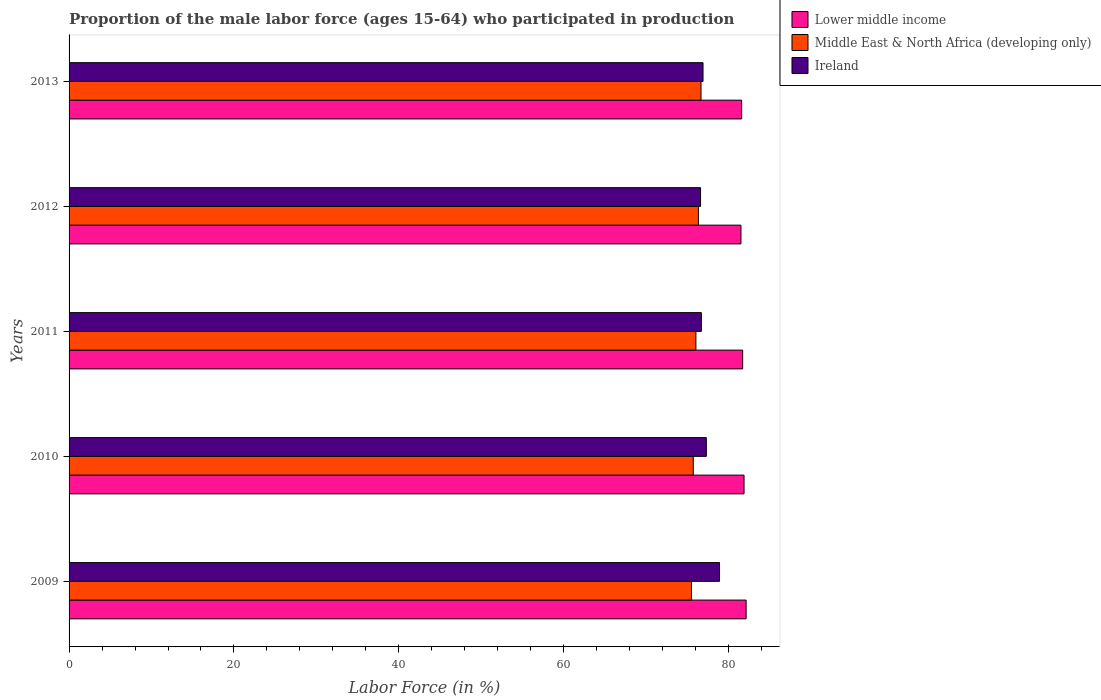Are the number of bars per tick equal to the number of legend labels?
Make the answer very short. Yes. Are the number of bars on each tick of the Y-axis equal?
Keep it short and to the point. Yes. What is the label of the 2nd group of bars from the top?
Provide a succinct answer. 2012. In how many cases, is the number of bars for a given year not equal to the number of legend labels?
Ensure brevity in your answer.  0. What is the proportion of the male labor force who participated in production in Middle East & North Africa (developing only) in 2013?
Keep it short and to the point. 76.65. Across all years, what is the maximum proportion of the male labor force who participated in production in Middle East & North Africa (developing only)?
Your answer should be compact. 76.65. Across all years, what is the minimum proportion of the male labor force who participated in production in Lower middle income?
Provide a succinct answer. 81.5. In which year was the proportion of the male labor force who participated in production in Ireland minimum?
Your response must be concise. 2012. What is the total proportion of the male labor force who participated in production in Lower middle income in the graph?
Your answer should be compact. 408.79. What is the difference between the proportion of the male labor force who participated in production in Middle East & North Africa (developing only) in 2009 and that in 2013?
Your response must be concise. -1.16. What is the difference between the proportion of the male labor force who participated in production in Lower middle income in 2009 and the proportion of the male labor force who participated in production in Middle East & North Africa (developing only) in 2011?
Offer a very short reply. 6.09. What is the average proportion of the male labor force who participated in production in Lower middle income per year?
Make the answer very short. 81.76. In the year 2010, what is the difference between the proportion of the male labor force who participated in production in Middle East & North Africa (developing only) and proportion of the male labor force who participated in production in Ireland?
Provide a succinct answer. -1.59. What is the ratio of the proportion of the male labor force who participated in production in Ireland in 2011 to that in 2013?
Keep it short and to the point. 1. Is the difference between the proportion of the male labor force who participated in production in Middle East & North Africa (developing only) in 2009 and 2010 greater than the difference between the proportion of the male labor force who participated in production in Ireland in 2009 and 2010?
Provide a short and direct response. No. What is the difference between the highest and the second highest proportion of the male labor force who participated in production in Middle East & North Africa (developing only)?
Your answer should be compact. 0.32. What is the difference between the highest and the lowest proportion of the male labor force who participated in production in Middle East & North Africa (developing only)?
Your answer should be compact. 1.16. Is the sum of the proportion of the male labor force who participated in production in Middle East & North Africa (developing only) in 2010 and 2013 greater than the maximum proportion of the male labor force who participated in production in Lower middle income across all years?
Provide a succinct answer. Yes. What does the 1st bar from the top in 2010 represents?
Your answer should be compact. Ireland. What does the 1st bar from the bottom in 2009 represents?
Provide a succinct answer. Lower middle income. How many years are there in the graph?
Offer a terse response. 5. Does the graph contain any zero values?
Keep it short and to the point. No. Where does the legend appear in the graph?
Your answer should be compact. Top right. How many legend labels are there?
Give a very brief answer. 3. What is the title of the graph?
Make the answer very short. Proportion of the male labor force (ages 15-64) who participated in production. What is the label or title of the X-axis?
Offer a terse response. Labor Force (in %). What is the Labor Force (in %) of Lower middle income in 2009?
Offer a terse response. 82.13. What is the Labor Force (in %) in Middle East & North Africa (developing only) in 2009?
Make the answer very short. 75.5. What is the Labor Force (in %) in Ireland in 2009?
Make the answer very short. 78.9. What is the Labor Force (in %) of Lower middle income in 2010?
Provide a short and direct response. 81.87. What is the Labor Force (in %) of Middle East & North Africa (developing only) in 2010?
Offer a terse response. 75.71. What is the Labor Force (in %) in Ireland in 2010?
Your answer should be very brief. 77.3. What is the Labor Force (in %) in Lower middle income in 2011?
Your answer should be very brief. 81.71. What is the Labor Force (in %) of Middle East & North Africa (developing only) in 2011?
Offer a very short reply. 76.03. What is the Labor Force (in %) of Ireland in 2011?
Offer a terse response. 76.7. What is the Labor Force (in %) in Lower middle income in 2012?
Offer a terse response. 81.5. What is the Labor Force (in %) of Middle East & North Africa (developing only) in 2012?
Make the answer very short. 76.33. What is the Labor Force (in %) in Ireland in 2012?
Your answer should be compact. 76.6. What is the Labor Force (in %) of Lower middle income in 2013?
Make the answer very short. 81.58. What is the Labor Force (in %) in Middle East & North Africa (developing only) in 2013?
Offer a terse response. 76.65. What is the Labor Force (in %) in Ireland in 2013?
Provide a short and direct response. 76.9. Across all years, what is the maximum Labor Force (in %) in Lower middle income?
Ensure brevity in your answer.  82.13. Across all years, what is the maximum Labor Force (in %) of Middle East & North Africa (developing only)?
Keep it short and to the point. 76.65. Across all years, what is the maximum Labor Force (in %) in Ireland?
Make the answer very short. 78.9. Across all years, what is the minimum Labor Force (in %) of Lower middle income?
Keep it short and to the point. 81.5. Across all years, what is the minimum Labor Force (in %) of Middle East & North Africa (developing only)?
Provide a short and direct response. 75.5. Across all years, what is the minimum Labor Force (in %) in Ireland?
Your answer should be compact. 76.6. What is the total Labor Force (in %) of Lower middle income in the graph?
Give a very brief answer. 408.79. What is the total Labor Force (in %) of Middle East & North Africa (developing only) in the graph?
Keep it short and to the point. 380.23. What is the total Labor Force (in %) of Ireland in the graph?
Your response must be concise. 386.4. What is the difference between the Labor Force (in %) of Lower middle income in 2009 and that in 2010?
Make the answer very short. 0.25. What is the difference between the Labor Force (in %) in Middle East & North Africa (developing only) in 2009 and that in 2010?
Provide a short and direct response. -0.22. What is the difference between the Labor Force (in %) in Lower middle income in 2009 and that in 2011?
Your answer should be very brief. 0.42. What is the difference between the Labor Force (in %) of Middle East & North Africa (developing only) in 2009 and that in 2011?
Provide a succinct answer. -0.54. What is the difference between the Labor Force (in %) in Ireland in 2009 and that in 2011?
Offer a terse response. 2.2. What is the difference between the Labor Force (in %) in Lower middle income in 2009 and that in 2012?
Make the answer very short. 0.63. What is the difference between the Labor Force (in %) in Middle East & North Africa (developing only) in 2009 and that in 2012?
Offer a terse response. -0.84. What is the difference between the Labor Force (in %) in Lower middle income in 2009 and that in 2013?
Your answer should be compact. 0.54. What is the difference between the Labor Force (in %) of Middle East & North Africa (developing only) in 2009 and that in 2013?
Your response must be concise. -1.16. What is the difference between the Labor Force (in %) of Ireland in 2009 and that in 2013?
Your response must be concise. 2. What is the difference between the Labor Force (in %) of Lower middle income in 2010 and that in 2011?
Offer a terse response. 0.17. What is the difference between the Labor Force (in %) of Middle East & North Africa (developing only) in 2010 and that in 2011?
Make the answer very short. -0.32. What is the difference between the Labor Force (in %) of Ireland in 2010 and that in 2011?
Offer a terse response. 0.6. What is the difference between the Labor Force (in %) of Lower middle income in 2010 and that in 2012?
Offer a terse response. 0.38. What is the difference between the Labor Force (in %) in Middle East & North Africa (developing only) in 2010 and that in 2012?
Make the answer very short. -0.62. What is the difference between the Labor Force (in %) in Lower middle income in 2010 and that in 2013?
Ensure brevity in your answer.  0.29. What is the difference between the Labor Force (in %) of Middle East & North Africa (developing only) in 2010 and that in 2013?
Offer a very short reply. -0.94. What is the difference between the Labor Force (in %) in Ireland in 2010 and that in 2013?
Ensure brevity in your answer.  0.4. What is the difference between the Labor Force (in %) in Lower middle income in 2011 and that in 2012?
Provide a succinct answer. 0.21. What is the difference between the Labor Force (in %) of Middle East & North Africa (developing only) in 2011 and that in 2012?
Provide a succinct answer. -0.3. What is the difference between the Labor Force (in %) of Ireland in 2011 and that in 2012?
Your response must be concise. 0.1. What is the difference between the Labor Force (in %) in Lower middle income in 2011 and that in 2013?
Make the answer very short. 0.12. What is the difference between the Labor Force (in %) of Middle East & North Africa (developing only) in 2011 and that in 2013?
Give a very brief answer. -0.62. What is the difference between the Labor Force (in %) in Ireland in 2011 and that in 2013?
Provide a succinct answer. -0.2. What is the difference between the Labor Force (in %) in Lower middle income in 2012 and that in 2013?
Give a very brief answer. -0.09. What is the difference between the Labor Force (in %) of Middle East & North Africa (developing only) in 2012 and that in 2013?
Your answer should be very brief. -0.32. What is the difference between the Labor Force (in %) of Ireland in 2012 and that in 2013?
Your answer should be compact. -0.3. What is the difference between the Labor Force (in %) in Lower middle income in 2009 and the Labor Force (in %) in Middle East & North Africa (developing only) in 2010?
Your response must be concise. 6.41. What is the difference between the Labor Force (in %) of Lower middle income in 2009 and the Labor Force (in %) of Ireland in 2010?
Ensure brevity in your answer.  4.83. What is the difference between the Labor Force (in %) of Middle East & North Africa (developing only) in 2009 and the Labor Force (in %) of Ireland in 2010?
Provide a succinct answer. -1.8. What is the difference between the Labor Force (in %) of Lower middle income in 2009 and the Labor Force (in %) of Middle East & North Africa (developing only) in 2011?
Your answer should be compact. 6.09. What is the difference between the Labor Force (in %) of Lower middle income in 2009 and the Labor Force (in %) of Ireland in 2011?
Your response must be concise. 5.43. What is the difference between the Labor Force (in %) in Middle East & North Africa (developing only) in 2009 and the Labor Force (in %) in Ireland in 2011?
Ensure brevity in your answer.  -1.2. What is the difference between the Labor Force (in %) in Lower middle income in 2009 and the Labor Force (in %) in Middle East & North Africa (developing only) in 2012?
Your response must be concise. 5.79. What is the difference between the Labor Force (in %) in Lower middle income in 2009 and the Labor Force (in %) in Ireland in 2012?
Keep it short and to the point. 5.53. What is the difference between the Labor Force (in %) in Middle East & North Africa (developing only) in 2009 and the Labor Force (in %) in Ireland in 2012?
Keep it short and to the point. -1.1. What is the difference between the Labor Force (in %) in Lower middle income in 2009 and the Labor Force (in %) in Middle East & North Africa (developing only) in 2013?
Give a very brief answer. 5.47. What is the difference between the Labor Force (in %) in Lower middle income in 2009 and the Labor Force (in %) in Ireland in 2013?
Keep it short and to the point. 5.23. What is the difference between the Labor Force (in %) in Middle East & North Africa (developing only) in 2009 and the Labor Force (in %) in Ireland in 2013?
Provide a short and direct response. -1.4. What is the difference between the Labor Force (in %) of Lower middle income in 2010 and the Labor Force (in %) of Middle East & North Africa (developing only) in 2011?
Your response must be concise. 5.84. What is the difference between the Labor Force (in %) in Lower middle income in 2010 and the Labor Force (in %) in Ireland in 2011?
Offer a very short reply. 5.17. What is the difference between the Labor Force (in %) of Middle East & North Africa (developing only) in 2010 and the Labor Force (in %) of Ireland in 2011?
Provide a short and direct response. -0.99. What is the difference between the Labor Force (in %) of Lower middle income in 2010 and the Labor Force (in %) of Middle East & North Africa (developing only) in 2012?
Ensure brevity in your answer.  5.54. What is the difference between the Labor Force (in %) of Lower middle income in 2010 and the Labor Force (in %) of Ireland in 2012?
Ensure brevity in your answer.  5.27. What is the difference between the Labor Force (in %) in Middle East & North Africa (developing only) in 2010 and the Labor Force (in %) in Ireland in 2012?
Keep it short and to the point. -0.89. What is the difference between the Labor Force (in %) in Lower middle income in 2010 and the Labor Force (in %) in Middle East & North Africa (developing only) in 2013?
Ensure brevity in your answer.  5.22. What is the difference between the Labor Force (in %) of Lower middle income in 2010 and the Labor Force (in %) of Ireland in 2013?
Offer a terse response. 4.97. What is the difference between the Labor Force (in %) of Middle East & North Africa (developing only) in 2010 and the Labor Force (in %) of Ireland in 2013?
Your answer should be very brief. -1.19. What is the difference between the Labor Force (in %) of Lower middle income in 2011 and the Labor Force (in %) of Middle East & North Africa (developing only) in 2012?
Offer a very short reply. 5.37. What is the difference between the Labor Force (in %) of Lower middle income in 2011 and the Labor Force (in %) of Ireland in 2012?
Provide a succinct answer. 5.11. What is the difference between the Labor Force (in %) in Middle East & North Africa (developing only) in 2011 and the Labor Force (in %) in Ireland in 2012?
Provide a short and direct response. -0.57. What is the difference between the Labor Force (in %) in Lower middle income in 2011 and the Labor Force (in %) in Middle East & North Africa (developing only) in 2013?
Make the answer very short. 5.05. What is the difference between the Labor Force (in %) in Lower middle income in 2011 and the Labor Force (in %) in Ireland in 2013?
Your answer should be compact. 4.81. What is the difference between the Labor Force (in %) in Middle East & North Africa (developing only) in 2011 and the Labor Force (in %) in Ireland in 2013?
Make the answer very short. -0.87. What is the difference between the Labor Force (in %) in Lower middle income in 2012 and the Labor Force (in %) in Middle East & North Africa (developing only) in 2013?
Keep it short and to the point. 4.84. What is the difference between the Labor Force (in %) of Lower middle income in 2012 and the Labor Force (in %) of Ireland in 2013?
Ensure brevity in your answer.  4.6. What is the difference between the Labor Force (in %) of Middle East & North Africa (developing only) in 2012 and the Labor Force (in %) of Ireland in 2013?
Ensure brevity in your answer.  -0.57. What is the average Labor Force (in %) of Lower middle income per year?
Provide a short and direct response. 81.76. What is the average Labor Force (in %) of Middle East & North Africa (developing only) per year?
Your response must be concise. 76.05. What is the average Labor Force (in %) of Ireland per year?
Offer a terse response. 77.28. In the year 2009, what is the difference between the Labor Force (in %) in Lower middle income and Labor Force (in %) in Middle East & North Africa (developing only)?
Provide a short and direct response. 6.63. In the year 2009, what is the difference between the Labor Force (in %) of Lower middle income and Labor Force (in %) of Ireland?
Your answer should be compact. 3.23. In the year 2009, what is the difference between the Labor Force (in %) of Middle East & North Africa (developing only) and Labor Force (in %) of Ireland?
Keep it short and to the point. -3.4. In the year 2010, what is the difference between the Labor Force (in %) of Lower middle income and Labor Force (in %) of Middle East & North Africa (developing only)?
Your answer should be very brief. 6.16. In the year 2010, what is the difference between the Labor Force (in %) of Lower middle income and Labor Force (in %) of Ireland?
Offer a very short reply. 4.57. In the year 2010, what is the difference between the Labor Force (in %) of Middle East & North Africa (developing only) and Labor Force (in %) of Ireland?
Make the answer very short. -1.59. In the year 2011, what is the difference between the Labor Force (in %) in Lower middle income and Labor Force (in %) in Middle East & North Africa (developing only)?
Your answer should be compact. 5.67. In the year 2011, what is the difference between the Labor Force (in %) of Lower middle income and Labor Force (in %) of Ireland?
Make the answer very short. 5.01. In the year 2011, what is the difference between the Labor Force (in %) of Middle East & North Africa (developing only) and Labor Force (in %) of Ireland?
Your response must be concise. -0.67. In the year 2012, what is the difference between the Labor Force (in %) of Lower middle income and Labor Force (in %) of Middle East & North Africa (developing only)?
Ensure brevity in your answer.  5.16. In the year 2012, what is the difference between the Labor Force (in %) of Lower middle income and Labor Force (in %) of Ireland?
Provide a succinct answer. 4.9. In the year 2012, what is the difference between the Labor Force (in %) in Middle East & North Africa (developing only) and Labor Force (in %) in Ireland?
Keep it short and to the point. -0.27. In the year 2013, what is the difference between the Labor Force (in %) of Lower middle income and Labor Force (in %) of Middle East & North Africa (developing only)?
Your answer should be compact. 4.93. In the year 2013, what is the difference between the Labor Force (in %) of Lower middle income and Labor Force (in %) of Ireland?
Keep it short and to the point. 4.68. In the year 2013, what is the difference between the Labor Force (in %) in Middle East & North Africa (developing only) and Labor Force (in %) in Ireland?
Provide a succinct answer. -0.25. What is the ratio of the Labor Force (in %) of Lower middle income in 2009 to that in 2010?
Keep it short and to the point. 1. What is the ratio of the Labor Force (in %) in Ireland in 2009 to that in 2010?
Your response must be concise. 1.02. What is the ratio of the Labor Force (in %) in Ireland in 2009 to that in 2011?
Your answer should be compact. 1.03. What is the ratio of the Labor Force (in %) in Lower middle income in 2009 to that in 2012?
Provide a short and direct response. 1.01. What is the ratio of the Labor Force (in %) of Ireland in 2009 to that in 2012?
Make the answer very short. 1.03. What is the ratio of the Labor Force (in %) of Lower middle income in 2009 to that in 2013?
Provide a short and direct response. 1.01. What is the ratio of the Labor Force (in %) of Middle East & North Africa (developing only) in 2009 to that in 2013?
Your answer should be very brief. 0.98. What is the ratio of the Labor Force (in %) in Lower middle income in 2010 to that in 2011?
Your answer should be compact. 1. What is the ratio of the Labor Force (in %) of Ireland in 2010 to that in 2012?
Your answer should be very brief. 1.01. What is the ratio of the Labor Force (in %) in Middle East & North Africa (developing only) in 2010 to that in 2013?
Offer a terse response. 0.99. What is the ratio of the Labor Force (in %) of Middle East & North Africa (developing only) in 2011 to that in 2012?
Make the answer very short. 1. What is the ratio of the Labor Force (in %) of Ireland in 2011 to that in 2012?
Provide a short and direct response. 1. What is the ratio of the Labor Force (in %) in Lower middle income in 2011 to that in 2013?
Ensure brevity in your answer.  1. What is the ratio of the Labor Force (in %) in Ireland in 2012 to that in 2013?
Give a very brief answer. 1. What is the difference between the highest and the second highest Labor Force (in %) in Lower middle income?
Offer a terse response. 0.25. What is the difference between the highest and the second highest Labor Force (in %) of Middle East & North Africa (developing only)?
Your response must be concise. 0.32. What is the difference between the highest and the lowest Labor Force (in %) in Lower middle income?
Ensure brevity in your answer.  0.63. What is the difference between the highest and the lowest Labor Force (in %) of Middle East & North Africa (developing only)?
Ensure brevity in your answer.  1.16. 